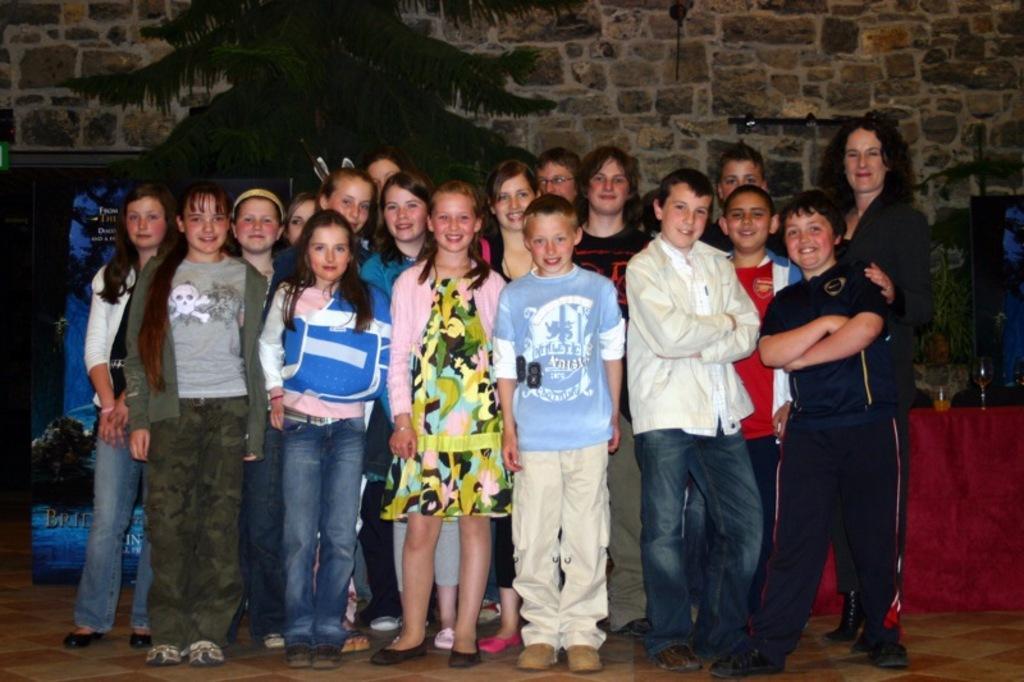In one or two sentences, can you explain what this image depicts? This picture seems to be clicked inside the hall. In the foreground we can see the group of people smiling and standing on the ground. On the right we can see a table on the top of which the glasses of drinks are placed. In the background we can see the stone wall and we can see the tree and the text and the depictions of some objects on the banner. In right corner there is an object. 